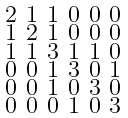<formula> <loc_0><loc_0><loc_500><loc_500>\begin{smallmatrix} 2 & 1 & 1 & 0 & 0 & 0 \\ 1 & 2 & 1 & 0 & 0 & 0 \\ 1 & 1 & 3 & 1 & 1 & 0 \\ 0 & 0 & 1 & 3 & 0 & 1 \\ 0 & 0 & 1 & 0 & 3 & 0 \\ 0 & 0 & 0 & 1 & 0 & 3 \end{smallmatrix}</formula> 